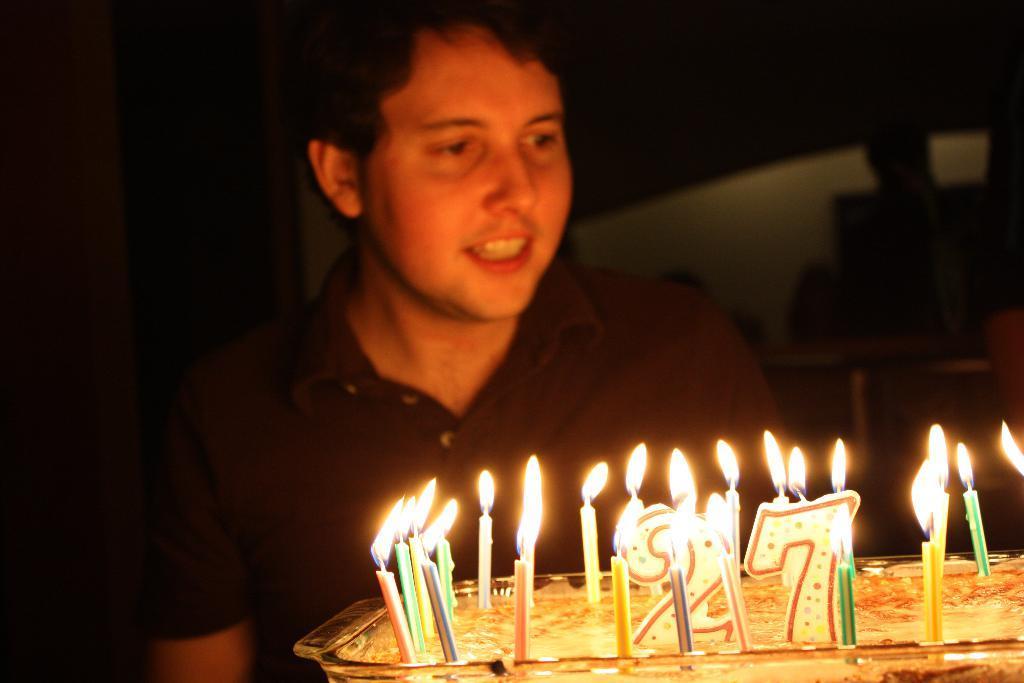In one or two sentences, can you explain what this image depicts? In the image there is a tray with cake. Inside the tray there are candles. Behind the the tray there's a man with black t-shirt. 